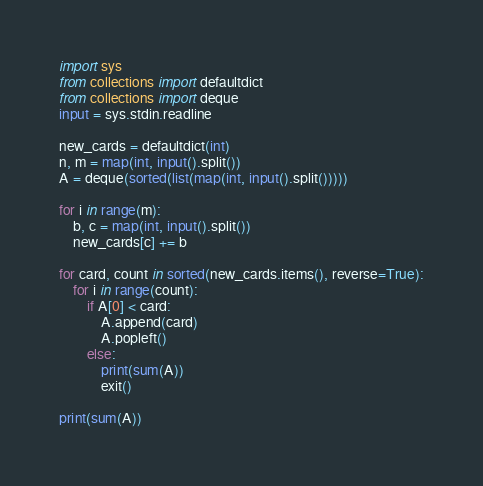<code> <loc_0><loc_0><loc_500><loc_500><_Python_>import sys
from collections import defaultdict
from collections import deque
input = sys.stdin.readline

new_cards = defaultdict(int)
n, m = map(int, input().split())
A = deque(sorted(list(map(int, input().split()))))

for i in range(m):
    b, c = map(int, input().split())
    new_cards[c] += b

for card, count in sorted(new_cards.items(), reverse=True):
    for i in range(count):
        if A[0] < card:
            A.append(card)
            A.popleft()
        else:
            print(sum(A))
            exit()

print(sum(A))

</code> 